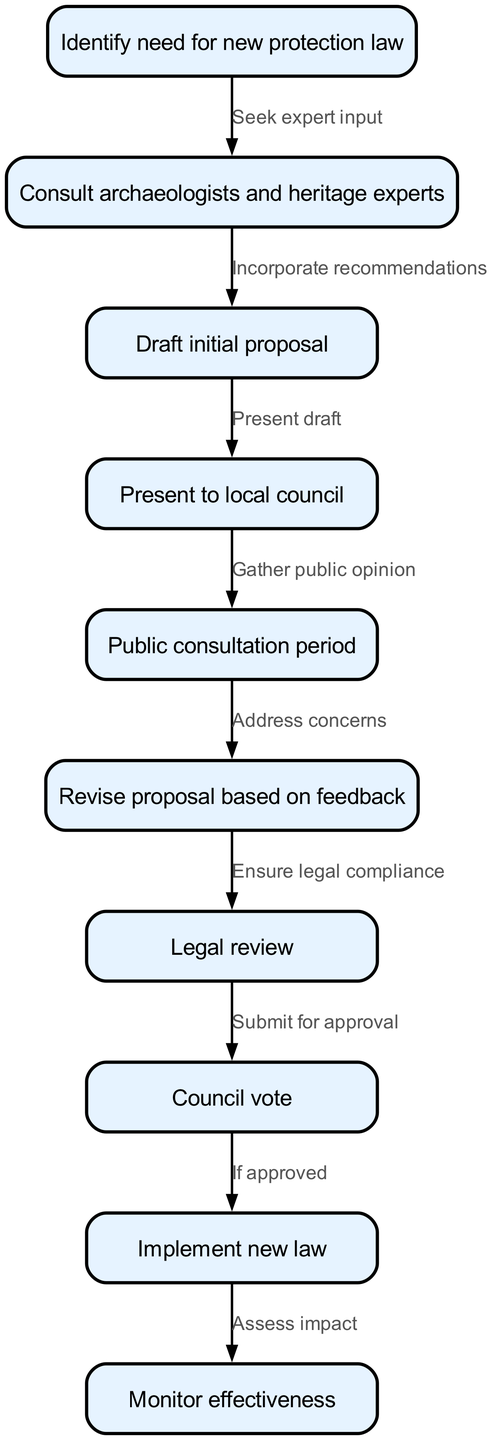What is the first step in proposing a new protection law? The diagram indicates that the first step is to "Identify need for new protection law." This is depicted as the starting node (id 1) of the flowchart, which leads to the next action.
Answer: Identify need for new protection law How many total nodes are in the diagram? By counting each node in the provided data, there are 10 unique nodes listed in the nodes section.
Answer: 10 What does the arrow from "Consult archaeologists and heritage experts" lead to? The flowchart shows that the edge from node 2 ("Consult archaeologists and heritage experts") points to node 3, which represents the next action to "Draft initial proposal."
Answer: Draft initial proposal What action follows the public consultation period? According to the diagram, the action that follows the public consultation period (node 5) is to "Revise proposal based on feedback" (node 6). The edge connecting these nodes indicates this sequence.
Answer: Revise proposal based on feedback What is the outcome if the council vote is approved? The flowchart indicates that if the council vote (node 8) is approved, the next step is to "Implement new law" (node 9). This is a conditional statement shown by the edge connecting the two nodes.
Answer: Implement new law What does the last action in the process focus on? The final action in the flowchart is to "Monitor effectiveness" (node 10). This indicates that after implementing the new law, there is a focus on assessing how well the law is working in practice.
Answer: Monitor effectiveness What is the primary purpose of seeking expert input in this flowchart? Seeking expert input (edge from node 1 to node 2) is primarily to incorporate informed recommendations into the proposal process. This step is aimed at ensuring that the new law is well-founded on expert knowledge.
Answer: Incorporate recommendations Which step requires addressing public concerns? The step that requires addressing public concerns is after the public consultation period, where it’s necessary to "Revise proposal based on feedback." This shows an engagement with public opinion to adjust the proposal accordingly.
Answer: Revise proposal based on feedback 